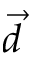<formula> <loc_0><loc_0><loc_500><loc_500>\vec { d }</formula> 